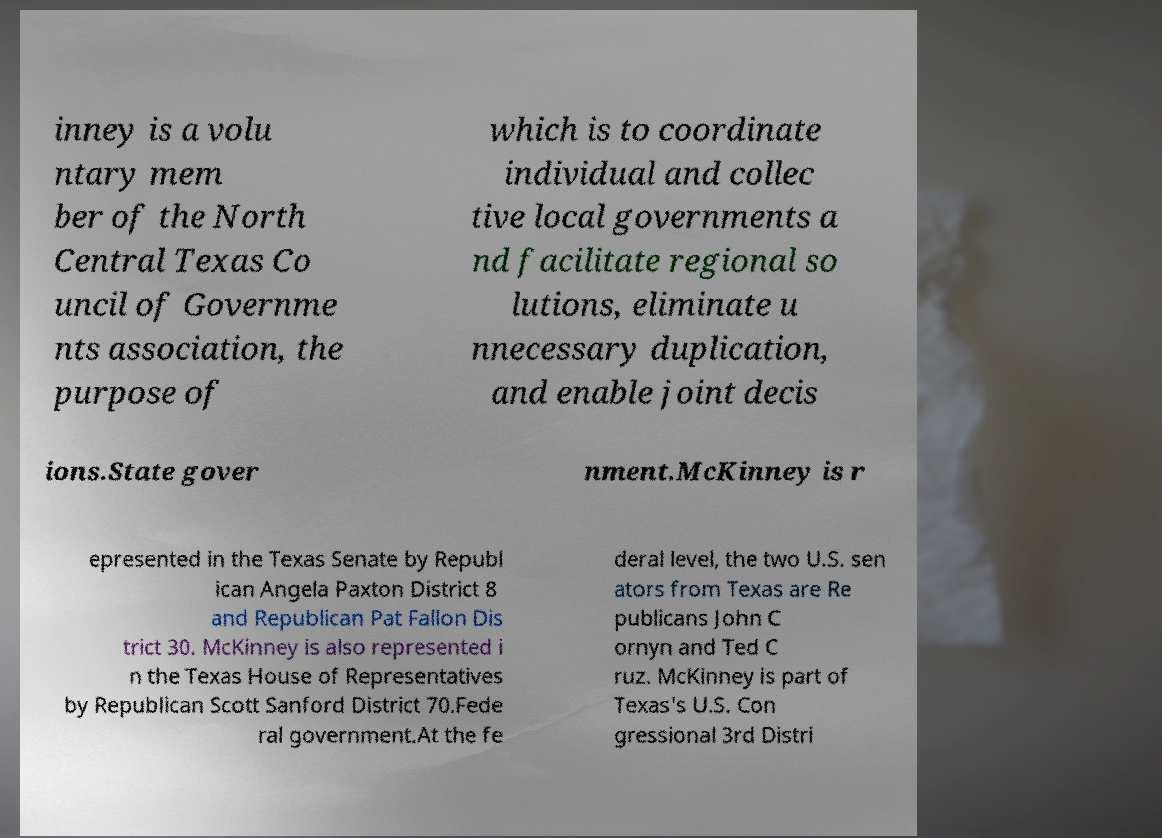There's text embedded in this image that I need extracted. Can you transcribe it verbatim? inney is a volu ntary mem ber of the North Central Texas Co uncil of Governme nts association, the purpose of which is to coordinate individual and collec tive local governments a nd facilitate regional so lutions, eliminate u nnecessary duplication, and enable joint decis ions.State gover nment.McKinney is r epresented in the Texas Senate by Republ ican Angela Paxton District 8 and Republican Pat Fallon Dis trict 30. McKinney is also represented i n the Texas House of Representatives by Republican Scott Sanford District 70.Fede ral government.At the fe deral level, the two U.S. sen ators from Texas are Re publicans John C ornyn and Ted C ruz. McKinney is part of Texas's U.S. Con gressional 3rd Distri 